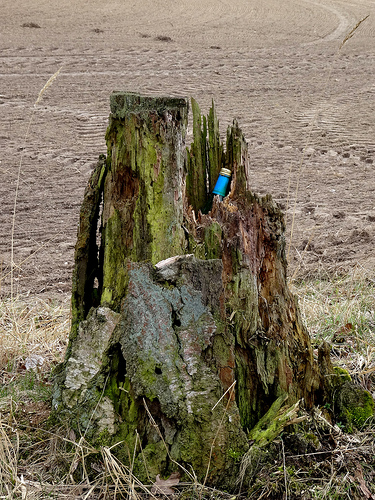<image>
Is there a bottle behind the stump? No. The bottle is not behind the stump. From this viewpoint, the bottle appears to be positioned elsewhere in the scene. 